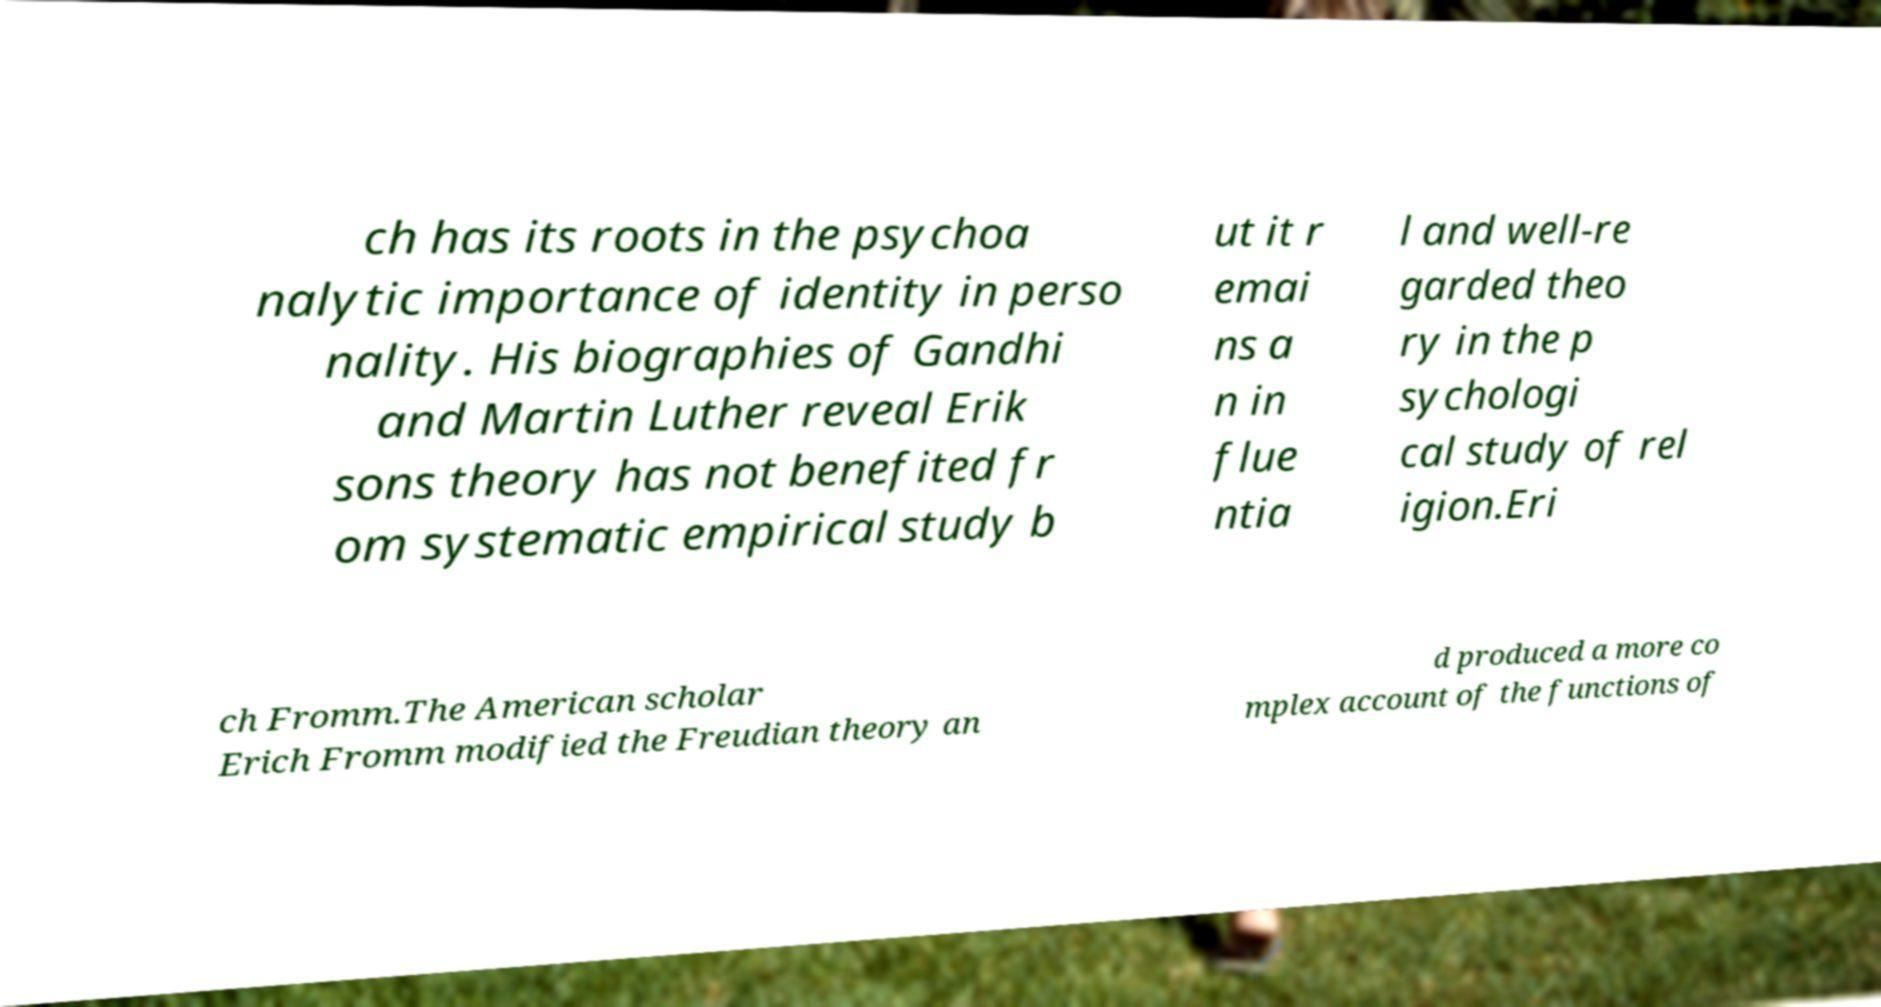I need the written content from this picture converted into text. Can you do that? ch has its roots in the psychoa nalytic importance of identity in perso nality. His biographies of Gandhi and Martin Luther reveal Erik sons theory has not benefited fr om systematic empirical study b ut it r emai ns a n in flue ntia l and well-re garded theo ry in the p sychologi cal study of rel igion.Eri ch Fromm.The American scholar Erich Fromm modified the Freudian theory an d produced a more co mplex account of the functions of 